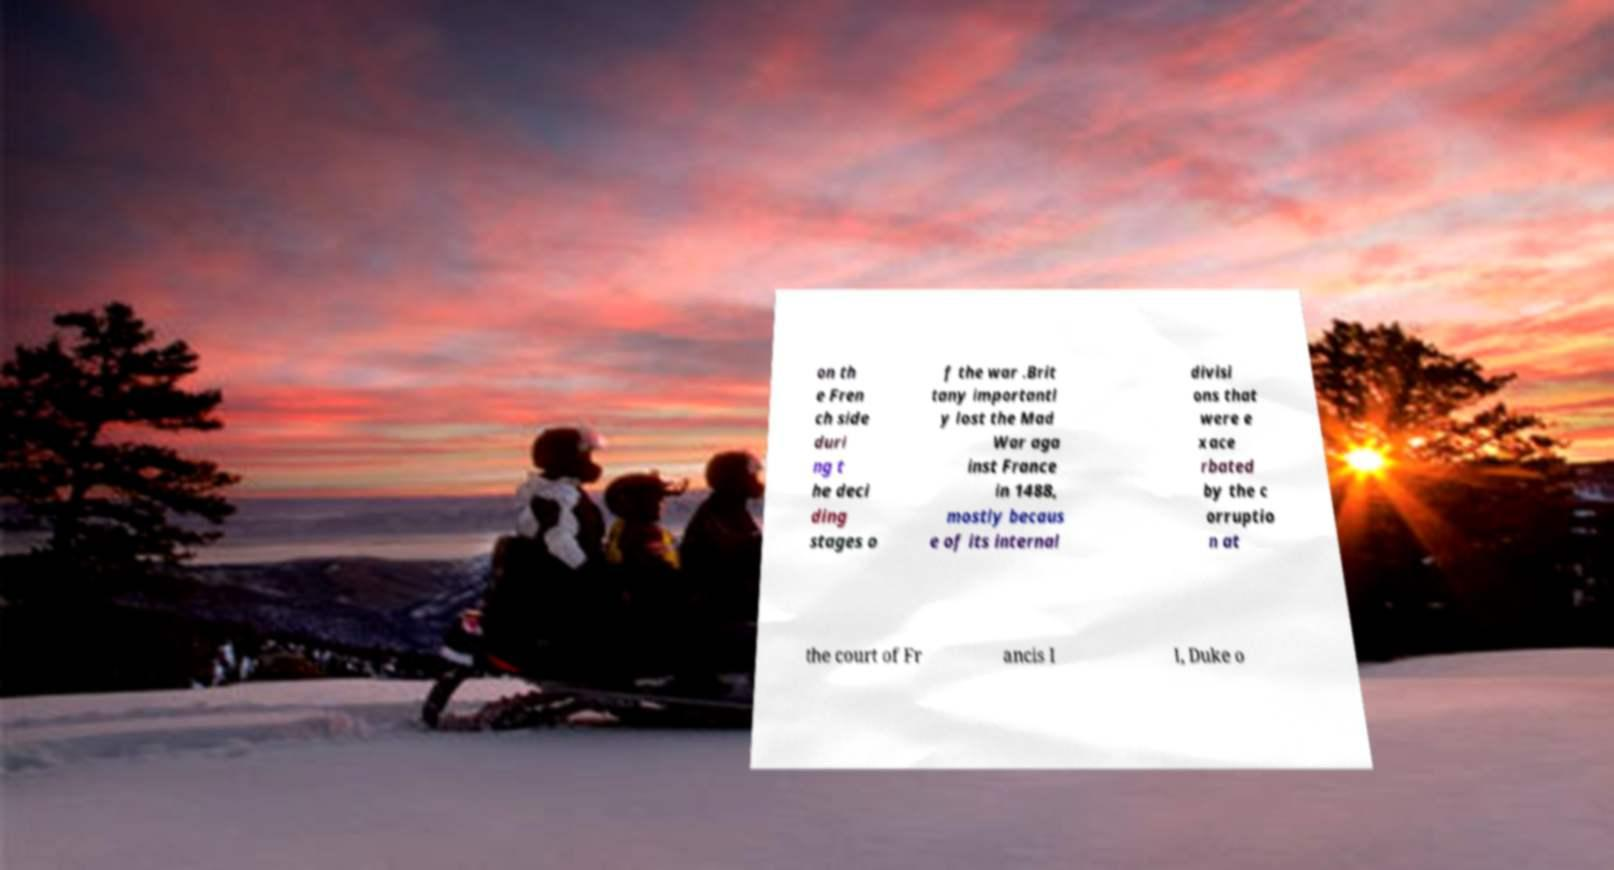For documentation purposes, I need the text within this image transcribed. Could you provide that? on th e Fren ch side duri ng t he deci ding stages o f the war .Brit tany importantl y lost the Mad War aga inst France in 1488, mostly becaus e of its internal divisi ons that were e xace rbated by the c orruptio n at the court of Fr ancis I I, Duke o 